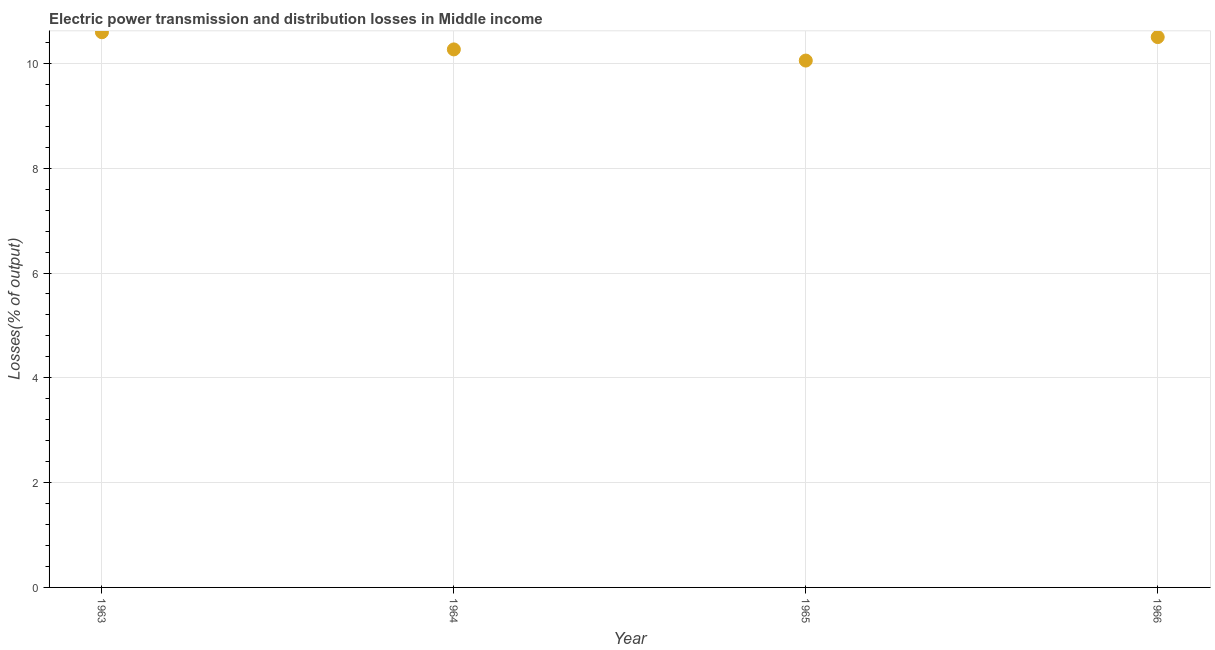What is the electric power transmission and distribution losses in 1964?
Your response must be concise. 10.27. Across all years, what is the maximum electric power transmission and distribution losses?
Keep it short and to the point. 10.6. Across all years, what is the minimum electric power transmission and distribution losses?
Give a very brief answer. 10.05. In which year was the electric power transmission and distribution losses maximum?
Your answer should be compact. 1963. In which year was the electric power transmission and distribution losses minimum?
Provide a short and direct response. 1965. What is the sum of the electric power transmission and distribution losses?
Offer a very short reply. 41.42. What is the difference between the electric power transmission and distribution losses in 1964 and 1966?
Provide a short and direct response. -0.24. What is the average electric power transmission and distribution losses per year?
Keep it short and to the point. 10.35. What is the median electric power transmission and distribution losses?
Your response must be concise. 10.38. In how many years, is the electric power transmission and distribution losses greater than 3.2 %?
Your response must be concise. 4. Do a majority of the years between 1964 and 1963 (inclusive) have electric power transmission and distribution losses greater than 7.6 %?
Your answer should be compact. No. What is the ratio of the electric power transmission and distribution losses in 1963 to that in 1966?
Your answer should be very brief. 1.01. Is the electric power transmission and distribution losses in 1963 less than that in 1964?
Offer a very short reply. No. What is the difference between the highest and the second highest electric power transmission and distribution losses?
Give a very brief answer. 0.09. Is the sum of the electric power transmission and distribution losses in 1963 and 1965 greater than the maximum electric power transmission and distribution losses across all years?
Your answer should be compact. Yes. What is the difference between the highest and the lowest electric power transmission and distribution losses?
Give a very brief answer. 0.54. Does the electric power transmission and distribution losses monotonically increase over the years?
Your answer should be very brief. No. Are the values on the major ticks of Y-axis written in scientific E-notation?
Make the answer very short. No. Does the graph contain grids?
Give a very brief answer. Yes. What is the title of the graph?
Provide a short and direct response. Electric power transmission and distribution losses in Middle income. What is the label or title of the X-axis?
Give a very brief answer. Year. What is the label or title of the Y-axis?
Your response must be concise. Losses(% of output). What is the Losses(% of output) in 1963?
Offer a very short reply. 10.6. What is the Losses(% of output) in 1964?
Provide a succinct answer. 10.27. What is the Losses(% of output) in 1965?
Give a very brief answer. 10.05. What is the Losses(% of output) in 1966?
Provide a short and direct response. 10.5. What is the difference between the Losses(% of output) in 1963 and 1964?
Give a very brief answer. 0.33. What is the difference between the Losses(% of output) in 1963 and 1965?
Provide a short and direct response. 0.54. What is the difference between the Losses(% of output) in 1963 and 1966?
Ensure brevity in your answer.  0.09. What is the difference between the Losses(% of output) in 1964 and 1965?
Offer a very short reply. 0.21. What is the difference between the Losses(% of output) in 1964 and 1966?
Make the answer very short. -0.24. What is the difference between the Losses(% of output) in 1965 and 1966?
Provide a short and direct response. -0.45. What is the ratio of the Losses(% of output) in 1963 to that in 1964?
Your answer should be very brief. 1.03. What is the ratio of the Losses(% of output) in 1963 to that in 1965?
Offer a very short reply. 1.05. What is the ratio of the Losses(% of output) in 1963 to that in 1966?
Your answer should be very brief. 1.01. What is the ratio of the Losses(% of output) in 1964 to that in 1965?
Make the answer very short. 1.02. What is the ratio of the Losses(% of output) in 1964 to that in 1966?
Provide a succinct answer. 0.98. 